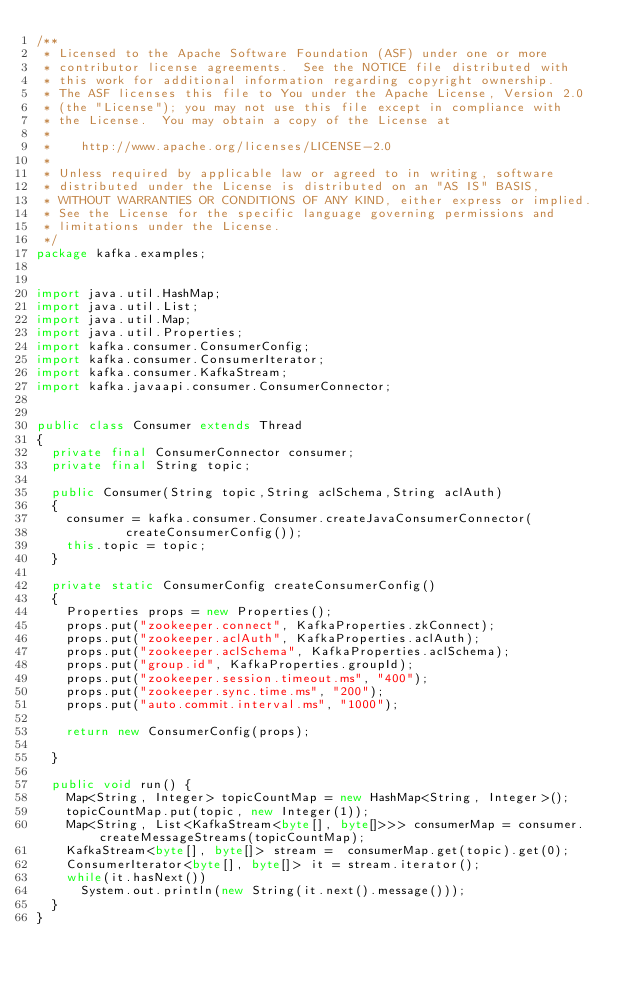Convert code to text. <code><loc_0><loc_0><loc_500><loc_500><_Java_>/**
 * Licensed to the Apache Software Foundation (ASF) under one or more
 * contributor license agreements.  See the NOTICE file distributed with
 * this work for additional information regarding copyright ownership.
 * The ASF licenses this file to You under the Apache License, Version 2.0
 * (the "License"); you may not use this file except in compliance with
 * the License.  You may obtain a copy of the License at
 * 
 *    http://www.apache.org/licenses/LICENSE-2.0
 *
 * Unless required by applicable law or agreed to in writing, software
 * distributed under the License is distributed on an "AS IS" BASIS,
 * WITHOUT WARRANTIES OR CONDITIONS OF ANY KIND, either express or implied.
 * See the License for the specific language governing permissions and
 * limitations under the License.
 */
package kafka.examples;


import java.util.HashMap;
import java.util.List;
import java.util.Map;
import java.util.Properties;
import kafka.consumer.ConsumerConfig;
import kafka.consumer.ConsumerIterator;
import kafka.consumer.KafkaStream;
import kafka.javaapi.consumer.ConsumerConnector;


public class Consumer extends Thread
{
  private final ConsumerConnector consumer;
  private final String topic;
  
  public Consumer(String topic,String aclSchema,String aclAuth)
  {
    consumer = kafka.consumer.Consumer.createJavaConsumerConnector(
            createConsumerConfig());
    this.topic = topic;
  }

  private static ConsumerConfig createConsumerConfig()
  {
    Properties props = new Properties();
    props.put("zookeeper.connect", KafkaProperties.zkConnect);
    props.put("zookeeper.aclAuth", KafkaProperties.aclAuth);
    props.put("zookeeper.aclSchema", KafkaProperties.aclSchema);
    props.put("group.id", KafkaProperties.groupId);
    props.put("zookeeper.session.timeout.ms", "400");
    props.put("zookeeper.sync.time.ms", "200");
    props.put("auto.commit.interval.ms", "1000");

    return new ConsumerConfig(props);

  }
 
  public void run() {
    Map<String, Integer> topicCountMap = new HashMap<String, Integer>();
    topicCountMap.put(topic, new Integer(1));
    Map<String, List<KafkaStream<byte[], byte[]>>> consumerMap = consumer.createMessageStreams(topicCountMap);
    KafkaStream<byte[], byte[]> stream =  consumerMap.get(topic).get(0);
    ConsumerIterator<byte[], byte[]> it = stream.iterator();
    while(it.hasNext())
      System.out.println(new String(it.next().message()));
  }
}
</code> 